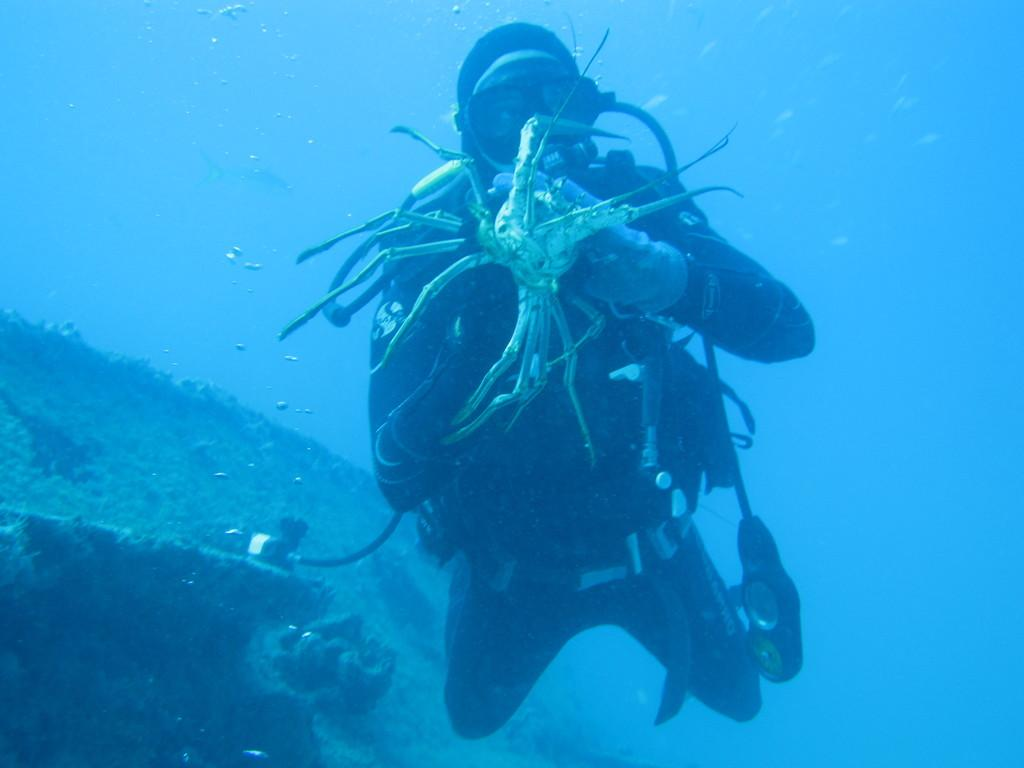What is the setting of the image? The image was taken underwater. What is the person in the image wearing? The person is wearing a costume in the image. What is the person doing in the image? The person is diving in the image. What is the person holding in the image? The person is holding a crab in the image. What can be seen in the background of the image? There are marine species visible in the background of the image. What type of rake is being used to collect leaves in the image? There is no rake present in the image, as it was taken underwater and not in a setting where leaves would be collected. 